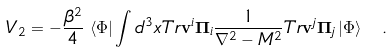<formula> <loc_0><loc_0><loc_500><loc_500>V _ { 2 } = - \frac { \beta ^ { 2 } } { 4 } \, \left \langle \Phi \right | \int { d ^ { 3 } } x T r { { \mathbf v } ^ { i } { \mathbf \Pi } _ { i } } \frac { 1 } { \nabla ^ { 2 } - M ^ { 2 } } T r { { \mathbf v } ^ { j } { \mathbf \Pi } _ { j } } \left | \Phi \right \rangle \ .</formula> 